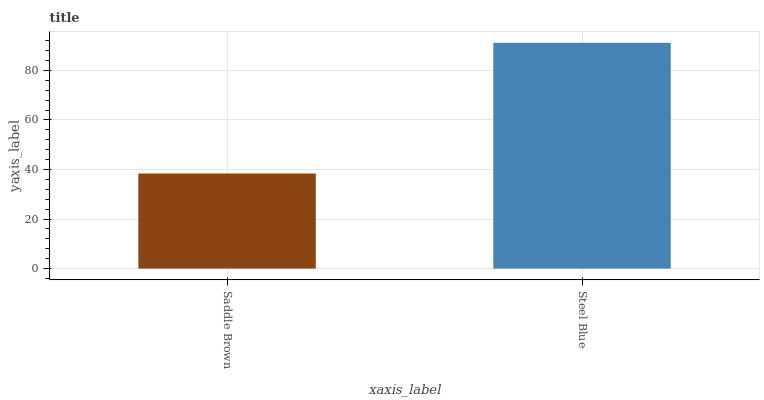Is Steel Blue the minimum?
Answer yes or no. No. Is Steel Blue greater than Saddle Brown?
Answer yes or no. Yes. Is Saddle Brown less than Steel Blue?
Answer yes or no. Yes. Is Saddle Brown greater than Steel Blue?
Answer yes or no. No. Is Steel Blue less than Saddle Brown?
Answer yes or no. No. Is Steel Blue the high median?
Answer yes or no. Yes. Is Saddle Brown the low median?
Answer yes or no. Yes. Is Saddle Brown the high median?
Answer yes or no. No. Is Steel Blue the low median?
Answer yes or no. No. 